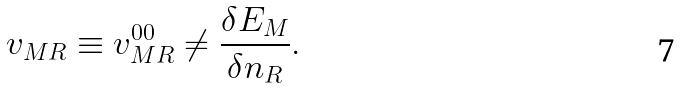Convert formula to latex. <formula><loc_0><loc_0><loc_500><loc_500>v _ { M { R } } \equiv v ^ { 0 0 } _ { M { R } } \neq \frac { \delta E _ { M } } { \delta n _ { R } } .</formula> 